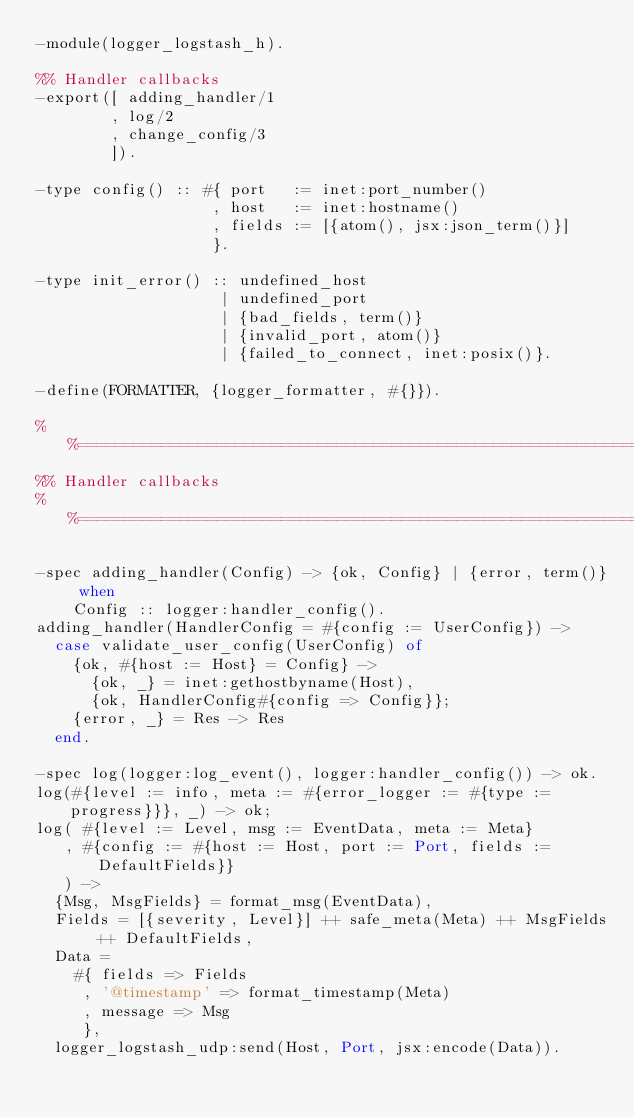<code> <loc_0><loc_0><loc_500><loc_500><_Erlang_>-module(logger_logstash_h).

%% Handler callbacks
-export([ adding_handler/1
        , log/2
        , change_config/3
        ]).

-type config() :: #{ port   := inet:port_number()
                   , host   := inet:hostname()
                   , fields := [{atom(), jsx:json_term()}]
                   }.

-type init_error() :: undefined_host
                    | undefined_port
                    | {bad_fields, term()}
                    | {invalid_port, atom()}
                    | {failed_to_connect, inet:posix()}.

-define(FORMATTER, {logger_formatter, #{}}).

%%==============================================================================================
%% Handler callbacks
%%==============================================================================================

-spec adding_handler(Config) -> {ok, Config} | {error, term()} when
    Config :: logger:handler_config().
adding_handler(HandlerConfig = #{config := UserConfig}) ->
  case validate_user_config(UserConfig) of
    {ok, #{host := Host} = Config} ->
      {ok, _} = inet:gethostbyname(Host),
      {ok, HandlerConfig#{config => Config}};
    {error, _} = Res -> Res
  end.

-spec log(logger:log_event(), logger:handler_config()) -> ok.
log(#{level := info, meta := #{error_logger := #{type := progress}}}, _) -> ok;
log( #{level := Level, msg := EventData, meta := Meta}
   , #{config := #{host := Host, port := Port, fields := DefaultFields}}
   ) ->
  {Msg, MsgFields} = format_msg(EventData),
  Fields = [{severity, Level}] ++ safe_meta(Meta) ++ MsgFields ++ DefaultFields,
  Data =
    #{ fields => Fields
     , '@timestamp' => format_timestamp(Meta)
     , message => Msg
     },
  logger_logstash_udp:send(Host, Port, jsx:encode(Data)).
</code> 